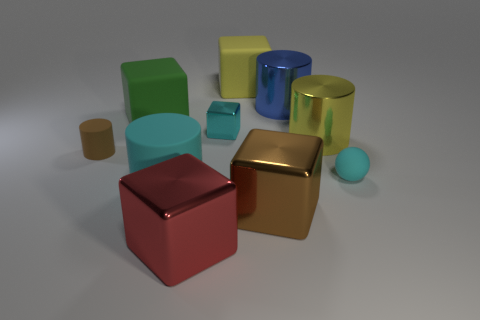Subtract all tiny shiny cubes. How many cubes are left? 4 Subtract all cyan cubes. How many cubes are left? 4 Add 9 cyan rubber cylinders. How many cyan rubber cylinders are left? 10 Add 2 tiny green metallic cylinders. How many tiny green metallic cylinders exist? 2 Subtract 1 blue cylinders. How many objects are left? 9 Subtract all cylinders. How many objects are left? 6 Subtract 2 cubes. How many cubes are left? 3 Subtract all brown cylinders. Subtract all cyan balls. How many cylinders are left? 3 Subtract all green cylinders. How many gray spheres are left? 0 Subtract all cyan metal cubes. Subtract all matte cylinders. How many objects are left? 7 